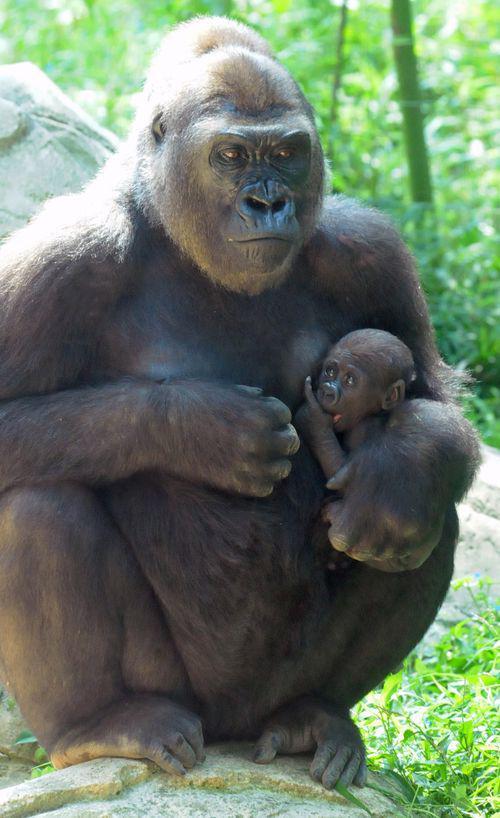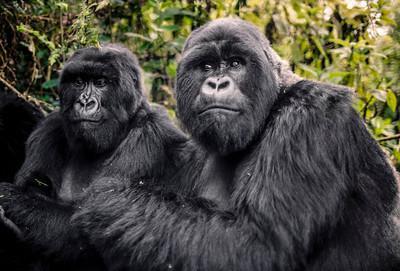The first image is the image on the left, the second image is the image on the right. For the images shown, is this caption "The right image shows exactly two apes, posed with their heads horizontal to one another." true? Answer yes or no. Yes. 